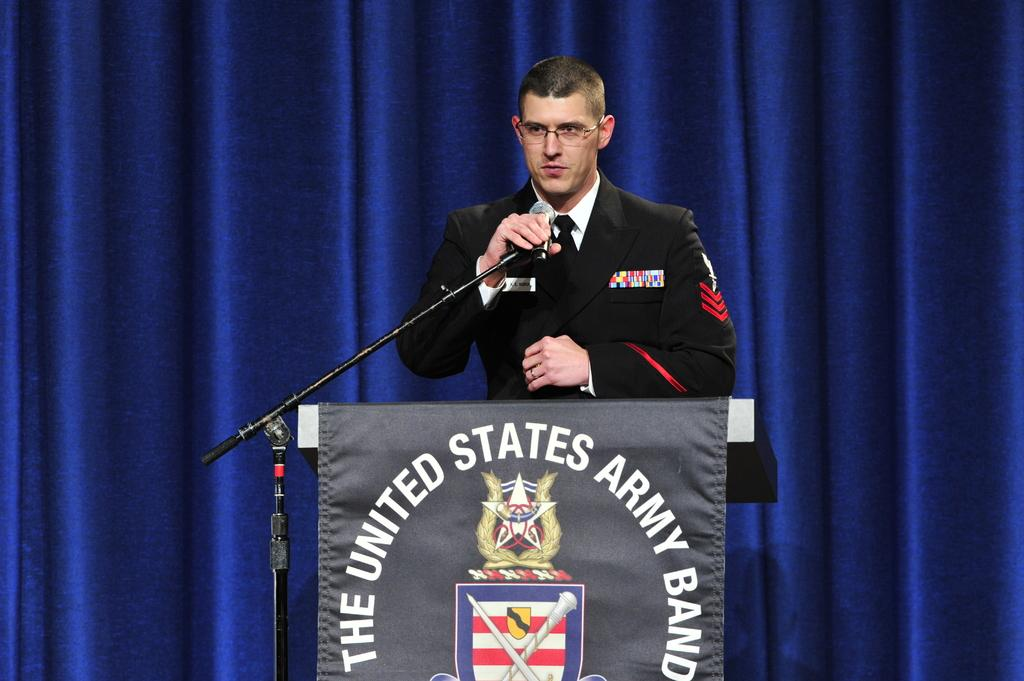<image>
Share a concise interpretation of the image provided. The podium reads The United States Army Band 